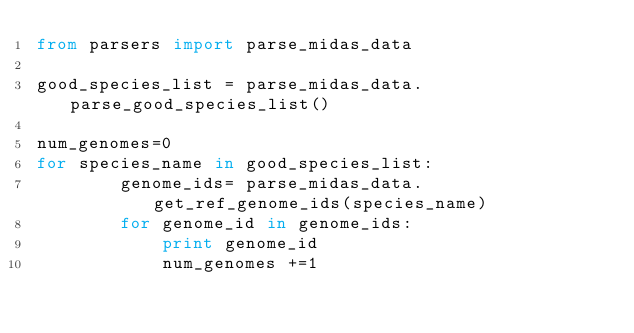<code> <loc_0><loc_0><loc_500><loc_500><_Python_>from parsers import parse_midas_data

good_species_list = parse_midas_data.parse_good_species_list()

num_genomes=0
for species_name in good_species_list: 
        genome_ids= parse_midas_data.get_ref_genome_ids(species_name)
        for genome_id in genome_ids:
            print genome_id
            num_genomes +=1
</code> 